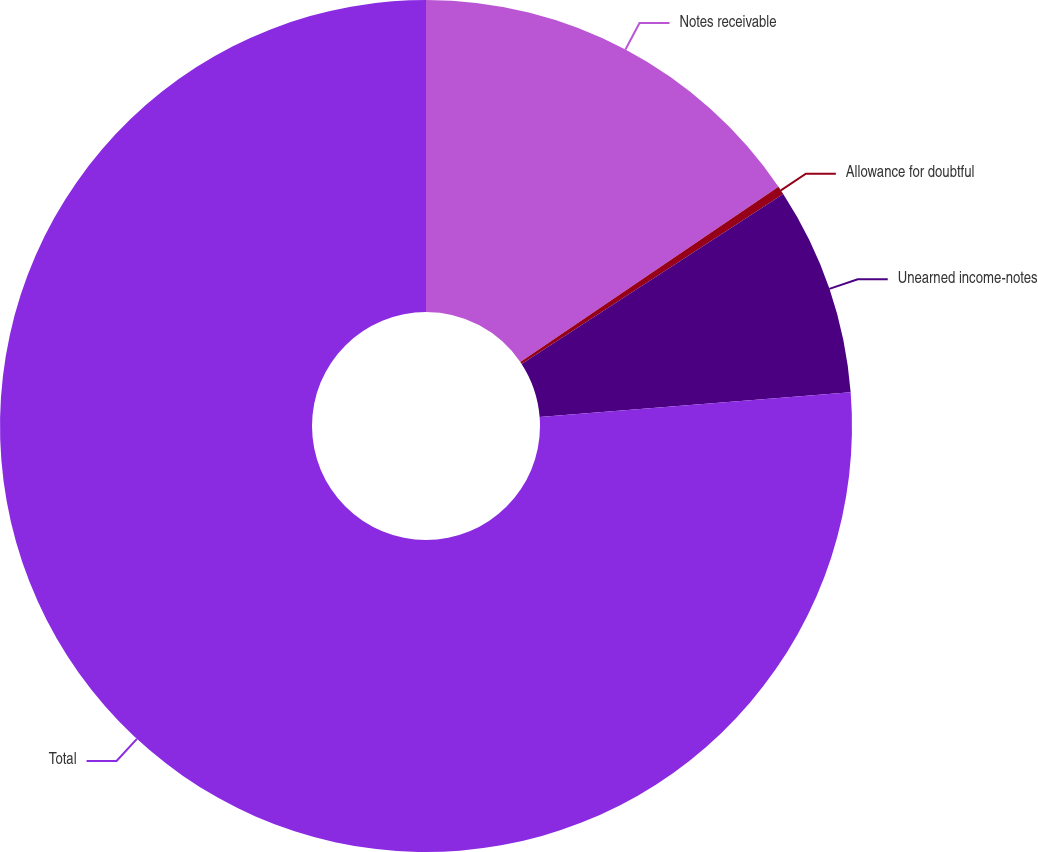Convert chart to OTSL. <chart><loc_0><loc_0><loc_500><loc_500><pie_chart><fcel>Notes receivable<fcel>Allowance for doubtful<fcel>Unearned income-notes<fcel>Total<nl><fcel>15.51%<fcel>0.32%<fcel>7.91%<fcel>76.26%<nl></chart> 